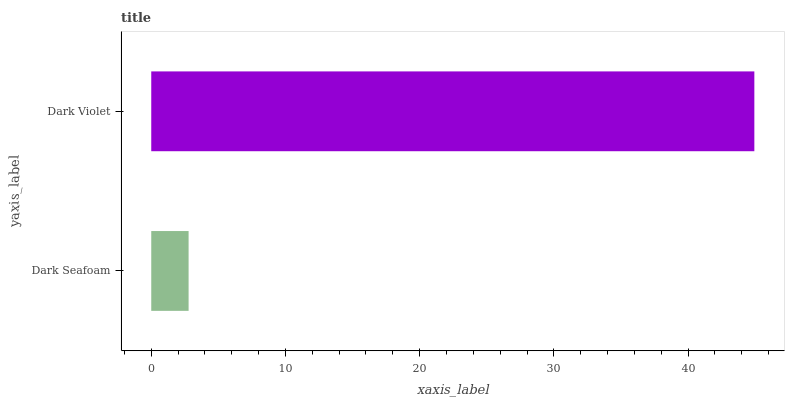Is Dark Seafoam the minimum?
Answer yes or no. Yes. Is Dark Violet the maximum?
Answer yes or no. Yes. Is Dark Violet the minimum?
Answer yes or no. No. Is Dark Violet greater than Dark Seafoam?
Answer yes or no. Yes. Is Dark Seafoam less than Dark Violet?
Answer yes or no. Yes. Is Dark Seafoam greater than Dark Violet?
Answer yes or no. No. Is Dark Violet less than Dark Seafoam?
Answer yes or no. No. Is Dark Violet the high median?
Answer yes or no. Yes. Is Dark Seafoam the low median?
Answer yes or no. Yes. Is Dark Seafoam the high median?
Answer yes or no. No. Is Dark Violet the low median?
Answer yes or no. No. 